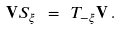<formula> <loc_0><loc_0><loc_500><loc_500>\mathbf V S _ { \xi } \ = \ T _ { - \xi } \mathbf V \, .</formula> 